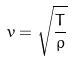<formula> <loc_0><loc_0><loc_500><loc_500>v = \sqrt { \frac { T } { \rho } }</formula> 